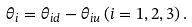Convert formula to latex. <formula><loc_0><loc_0><loc_500><loc_500>\theta _ { i } = \theta _ { i d } - \theta _ { i u } \, ( i = 1 , 2 , 3 ) \, .</formula> 